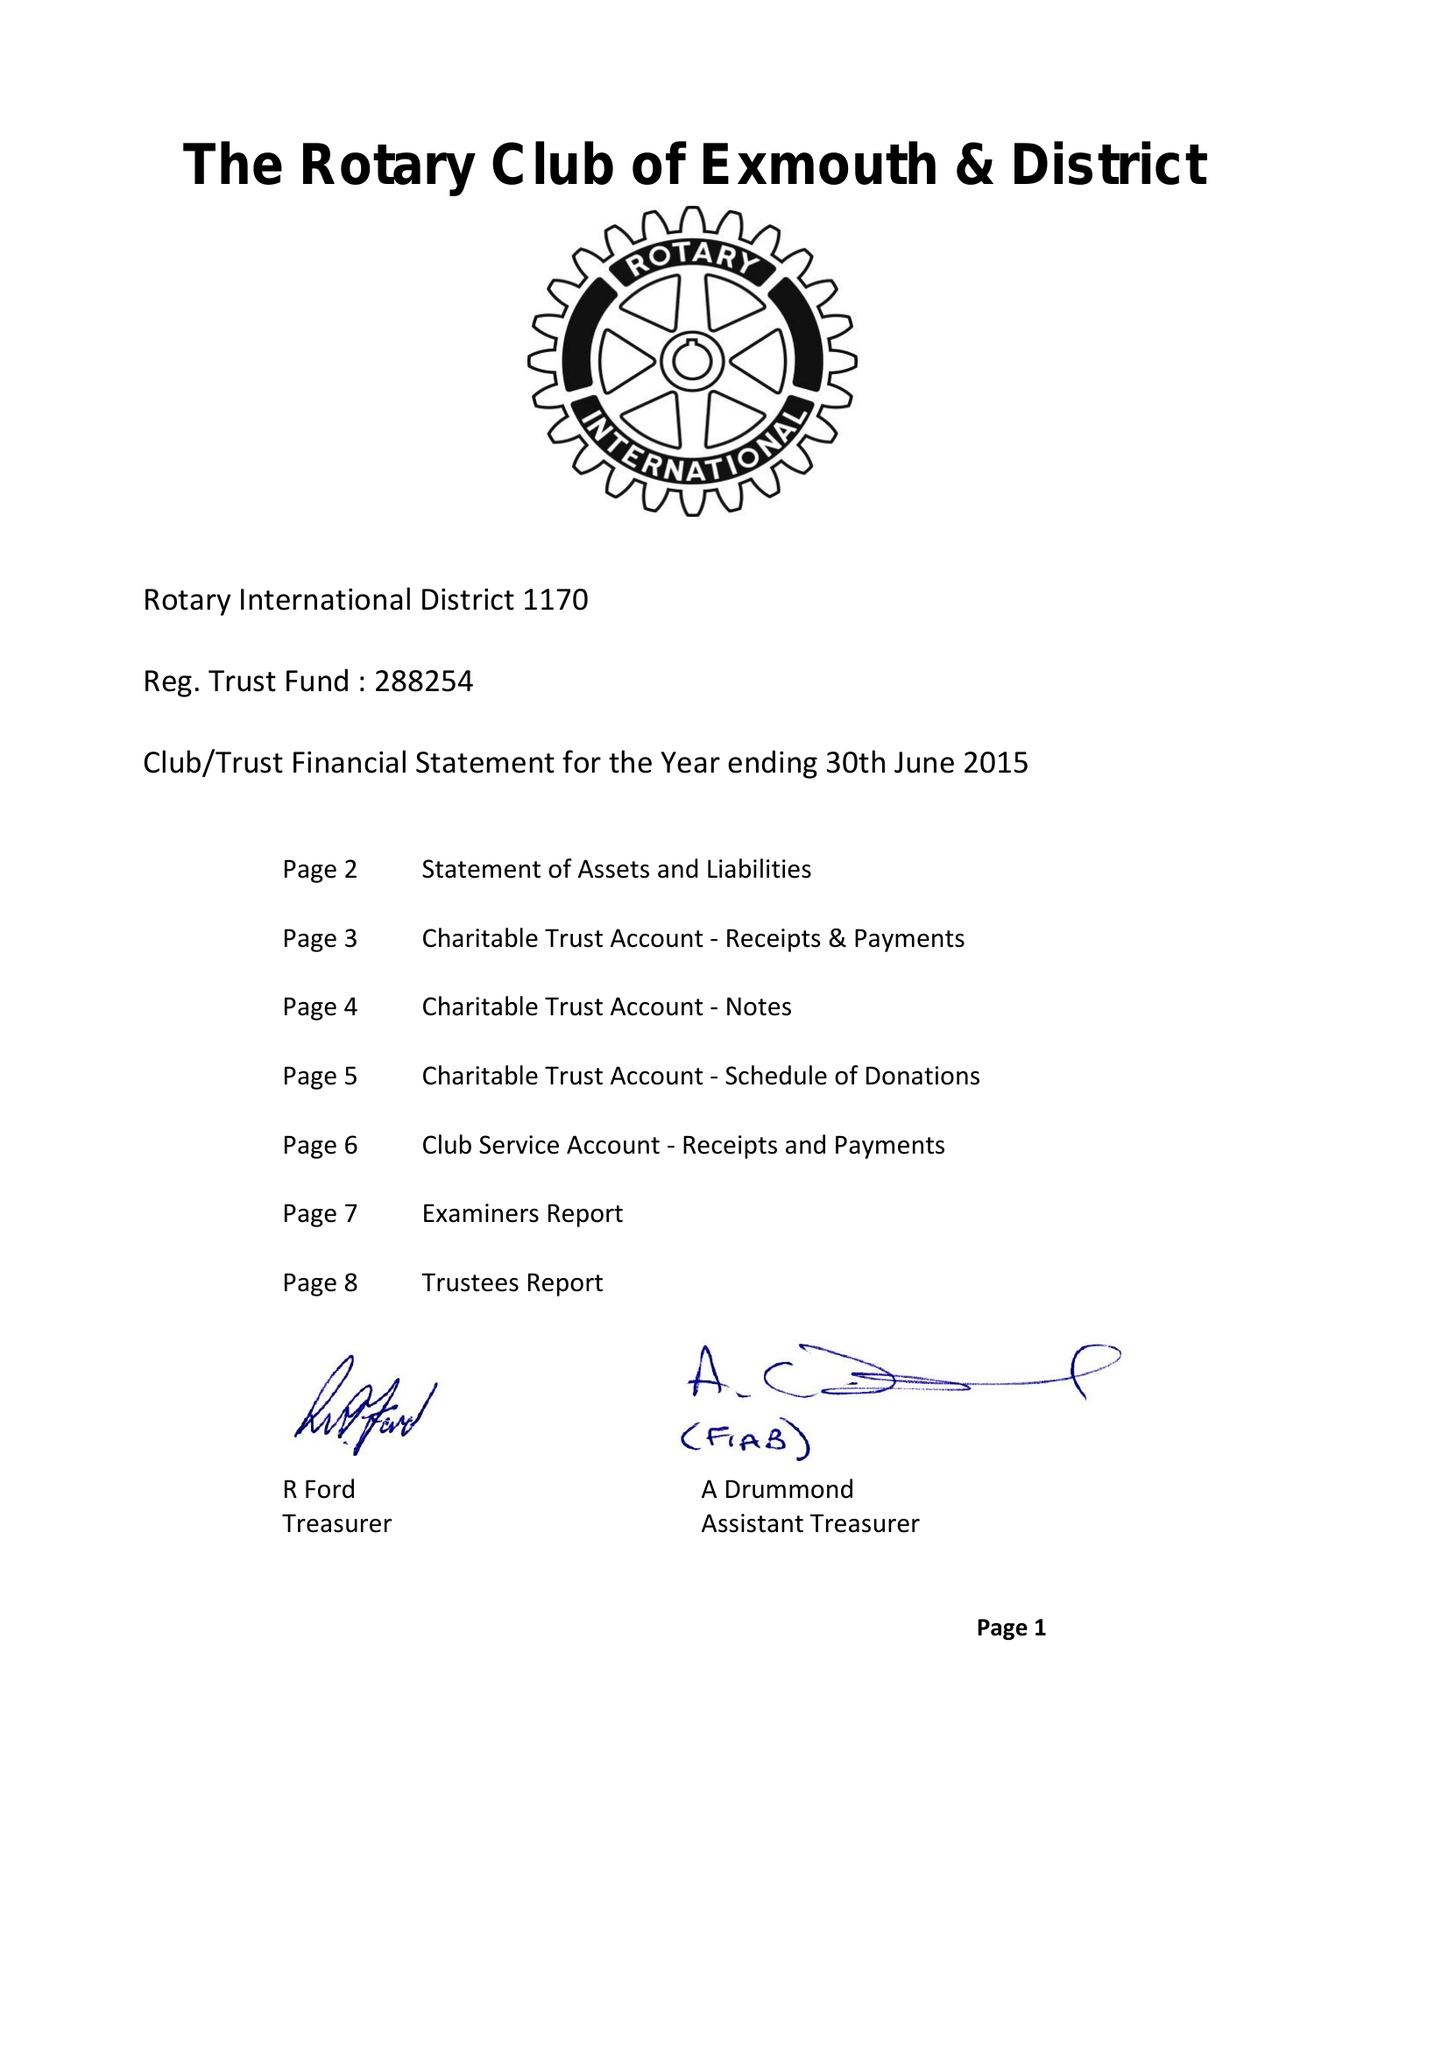What is the value for the charity_name?
Answer the question using a single word or phrase. The Rotary Club Of Exmouth Trust Fund 